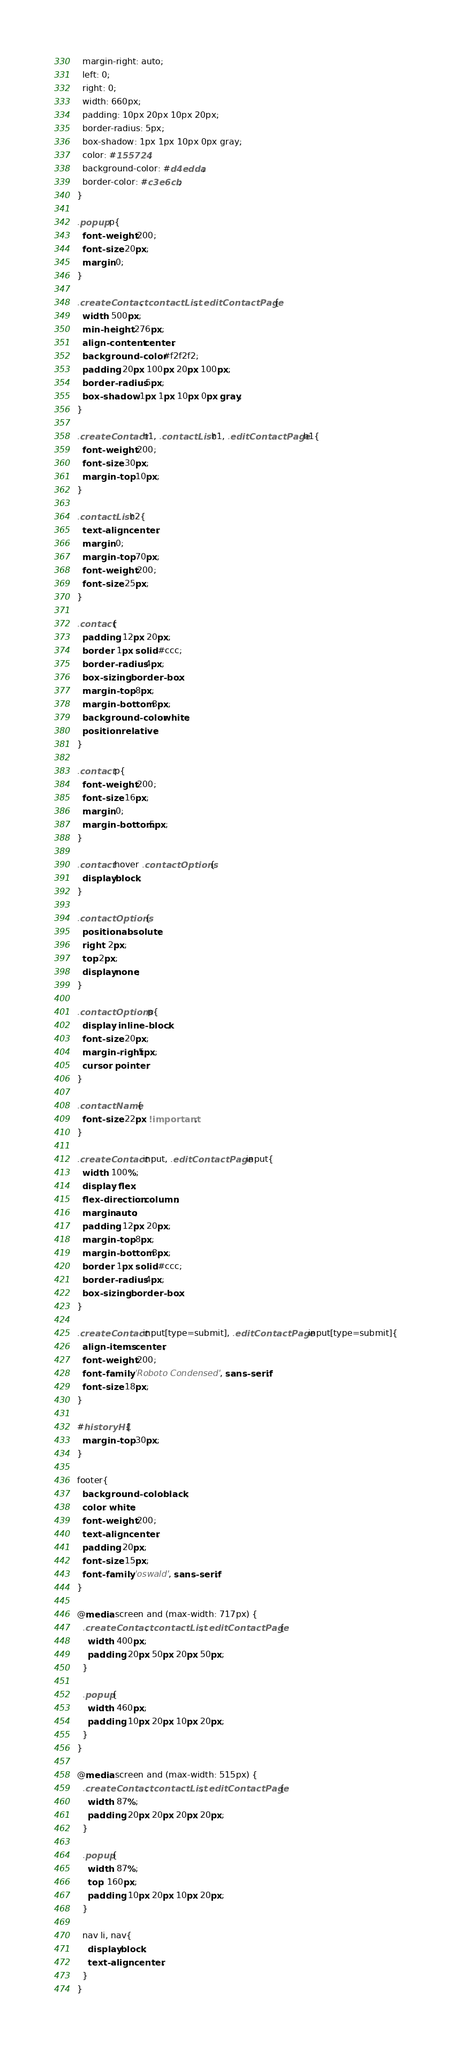<code> <loc_0><loc_0><loc_500><loc_500><_CSS_>  margin-right: auto;
  left: 0;
  right: 0;
  width: 660px;
  padding: 10px 20px 10px 20px;
  border-radius: 5px;
  box-shadow: 1px 1px 10px 0px gray;
  color: #155724;
  background-color: #d4edda;
  border-color: #c3e6cb;
}

.popup p{
  font-weight: 200;
  font-size: 20px;
  margin:0;
}

.createContact, .contactList, .editContactPage{
  width: 500px;
  min-height: 276px;
  align-content: center;
  background-color: #f2f2f2;
  padding: 20px 100px 20px 100px;
  border-radius: 5px;
  box-shadow: 1px 1px 10px 0px gray;
}

.createContact h1, .contactList h1, .editContactPage h1{
  font-weight: 200;
  font-size: 30px;
  margin-top: 10px;
}

.contactList h2{
  text-align: center;
  margin:0;
  margin-top: 70px;
  font-weight: 200;
  font-size: 25px;
}

.contact{
  padding: 12px 20px;
  border: 1px solid #ccc;
  border-radius: 4px;
  box-sizing: border-box;
  margin-top: 8px;
  margin-bottom: 8px;
  background-color: white;
  position: relative;
}

.contact p{
  font-weight: 200;
  font-size: 16px;
  margin:0;
  margin-bottom:5px;
}

.contact:hover .contactOptions{
  display:block;
}

.contactOptions{
  position: absolute;
  right: 2px;
  top:2px;
  display:none;
}

.contactOptions p{
  display: inline-block;
  font-size: 20px;
  margin-right:5px;
  cursor: pointer;
}

.contactName{
  font-size: 22px !important;
}

.createContact input, .editContactPage input{
  width: 100%;
  display: flex;
  flex-direction: column;
  margin:auto;
  padding: 12px 20px;
  margin-top: 8px;
  margin-bottom: 8px;
  border: 1px solid #ccc;
  border-radius: 4px;
  box-sizing: border-box;
}

.createContact input[type=submit], .editContactPage input[type=submit]{
  align-items: center;
  font-weight: 200;
  font-family: 'Roboto Condensed', sans-serif;
  font-size: 18px;
}

#historyH1{
  margin-top: 30px;
}

footer{
  background-color: black;
  color: white;
  font-weight: 200;
  text-align: center;
  padding: 20px;
  font-size: 15px;
  font-family: 'oswald', sans-serif;
}

@media screen and (max-width: 717px) {
  .createContact, .contactList, .editContactPage{
    width: 400px;
    padding: 20px 50px 20px 50px;
  }

  .popup{
    width: 460px;
    padding: 10px 20px 10px 20px;
  }
}

@media screen and (max-width: 515px) {
  .createContact, .contactList, .editContactPage{
    width: 87%;
    padding: 20px 20px 20px 20px;
  }

  .popup{
    width: 87%;
    top: 160px;
    padding: 10px 20px 10px 20px;
  }

  nav li, nav{
    display:block;
    text-align: center;
  }
}</code> 